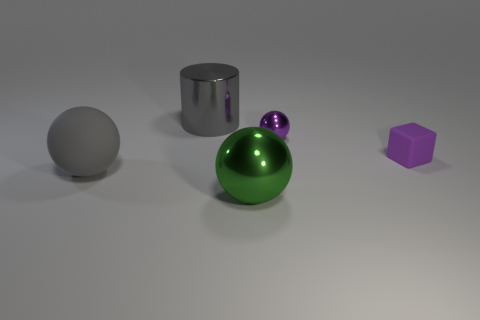Which of the objects in the image has the smoothest surface? The chrome cylinder and the metallic sphere reflect light in a way that suggests they have very smooth surfaces, but between the two, the cylinder has a smoother appearance due to its clear and undistorted reflection. 